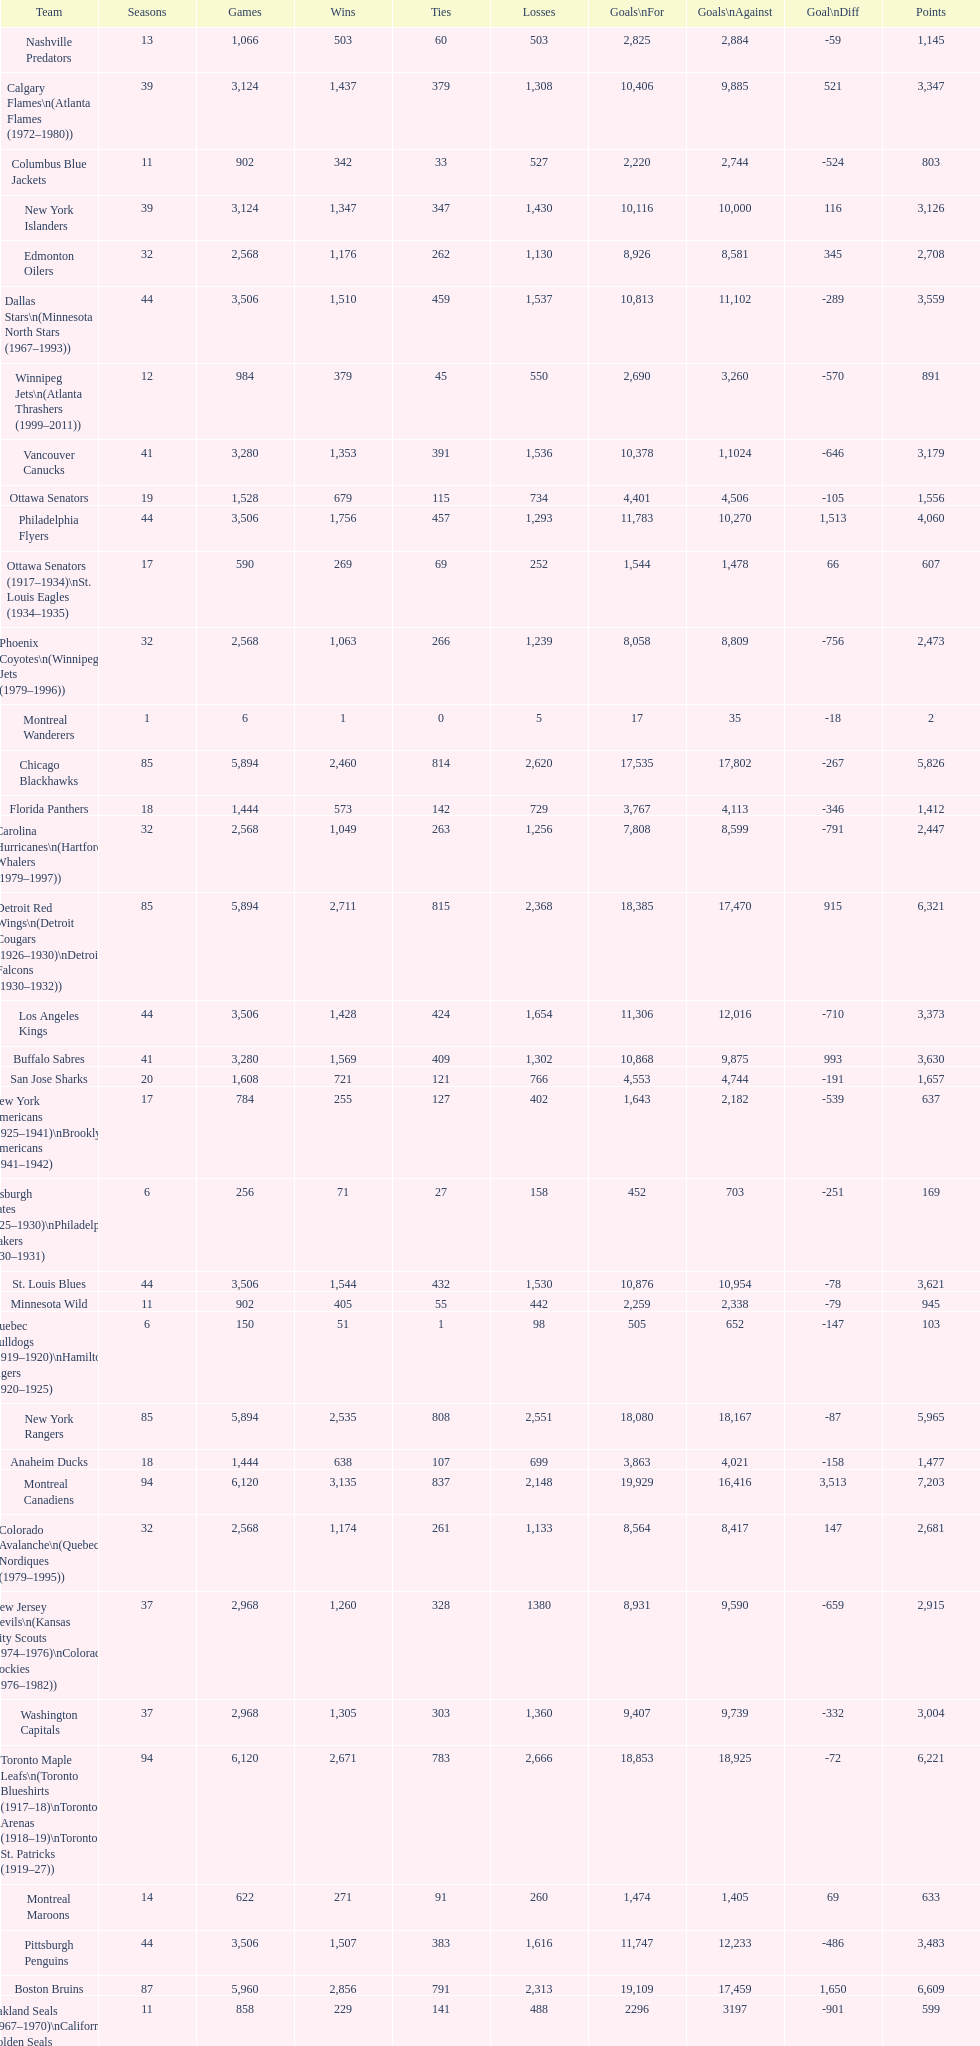How many total points has the lost angeles kings scored? 3,373. 